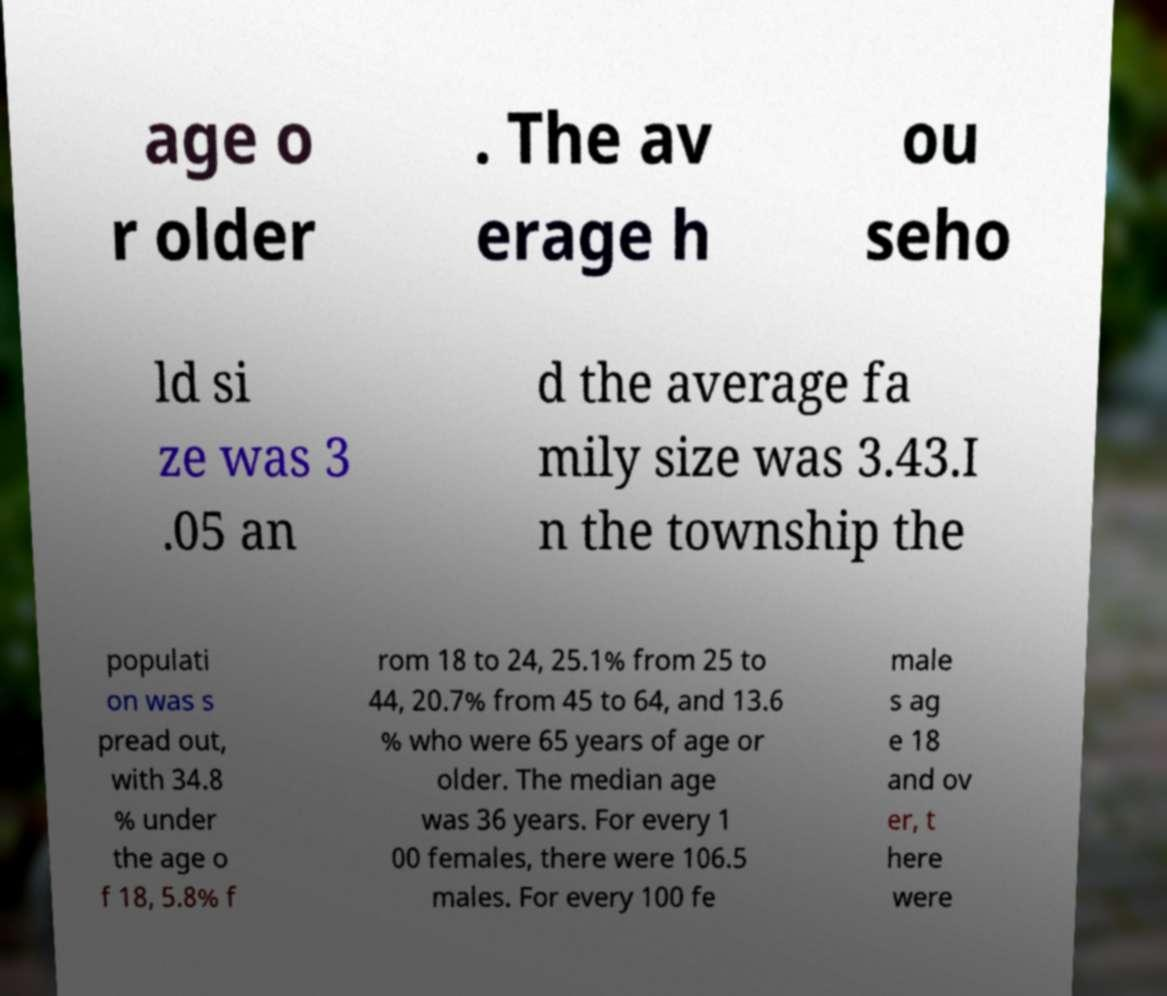For documentation purposes, I need the text within this image transcribed. Could you provide that? age o r older . The av erage h ou seho ld si ze was 3 .05 an d the average fa mily size was 3.43.I n the township the populati on was s pread out, with 34.8 % under the age o f 18, 5.8% f rom 18 to 24, 25.1% from 25 to 44, 20.7% from 45 to 64, and 13.6 % who were 65 years of age or older. The median age was 36 years. For every 1 00 females, there were 106.5 males. For every 100 fe male s ag e 18 and ov er, t here were 